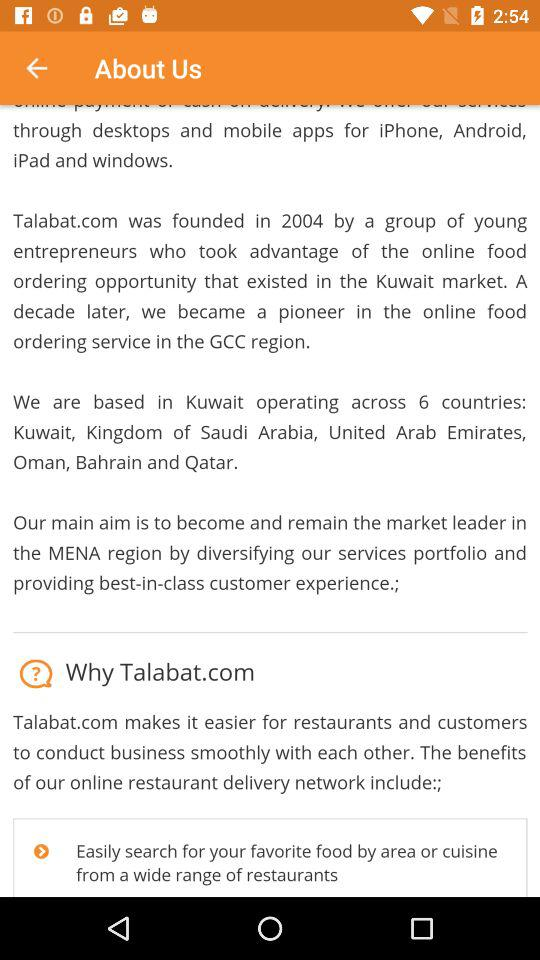When was Talabad.com founded? Talabad.com was founded in 2004. 